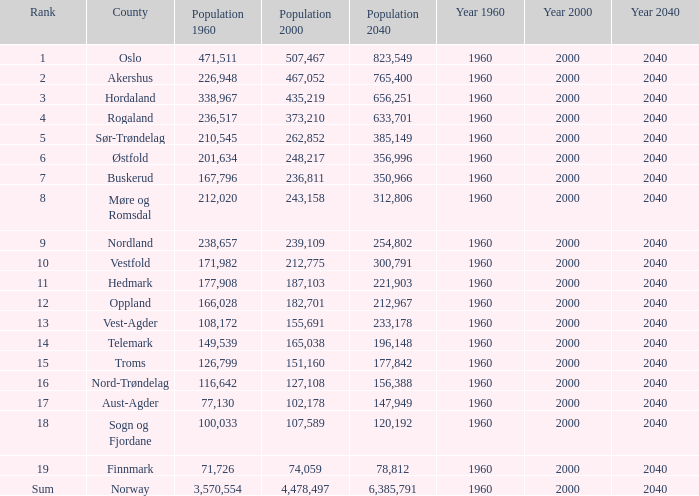In a county with a population of under 108,172 in 2000 and under 107,589 in 1960, what was the population in 2040? 2.0. 